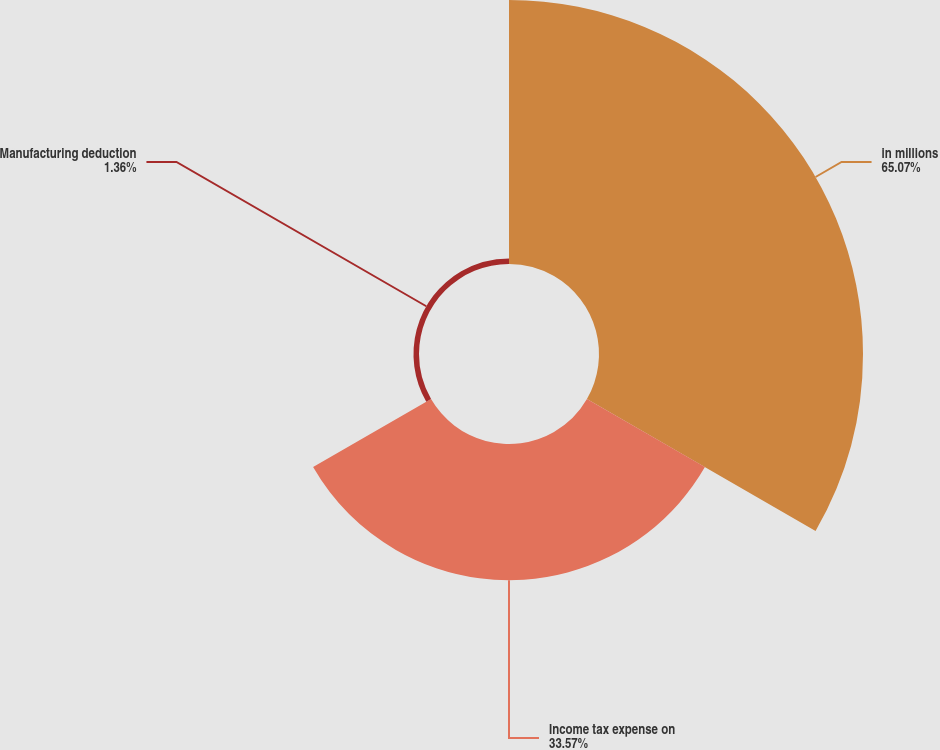<chart> <loc_0><loc_0><loc_500><loc_500><pie_chart><fcel>in millions<fcel>Income tax expense on<fcel>Manufacturing deduction<nl><fcel>65.07%<fcel>33.57%<fcel>1.36%<nl></chart> 